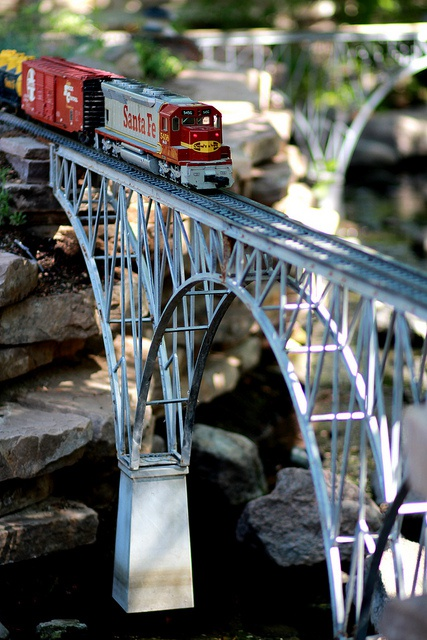Describe the objects in this image and their specific colors. I can see a train in tan, black, maroon, darkgray, and brown tones in this image. 